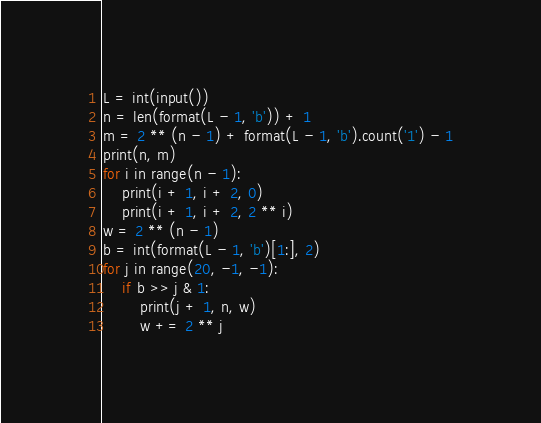Convert code to text. <code><loc_0><loc_0><loc_500><loc_500><_Python_>L = int(input())
n = len(format(L - 1, 'b')) + 1
m = 2 ** (n - 1) + format(L - 1, 'b').count('1') - 1
print(n, m)
for i in range(n - 1):
    print(i + 1, i + 2, 0)
    print(i + 1, i + 2, 2 ** i)
w = 2 ** (n - 1)
b = int(format(L - 1, 'b')[1:], 2)
for j in range(20, -1, -1):
    if b >> j & 1:
        print(j + 1, n, w)
        w += 2 ** j</code> 